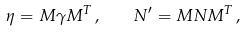<formula> <loc_0><loc_0><loc_500><loc_500>\eta = M \gamma M ^ { T } \, , \quad N ^ { \prime } = M N M ^ { T } \, ,</formula> 